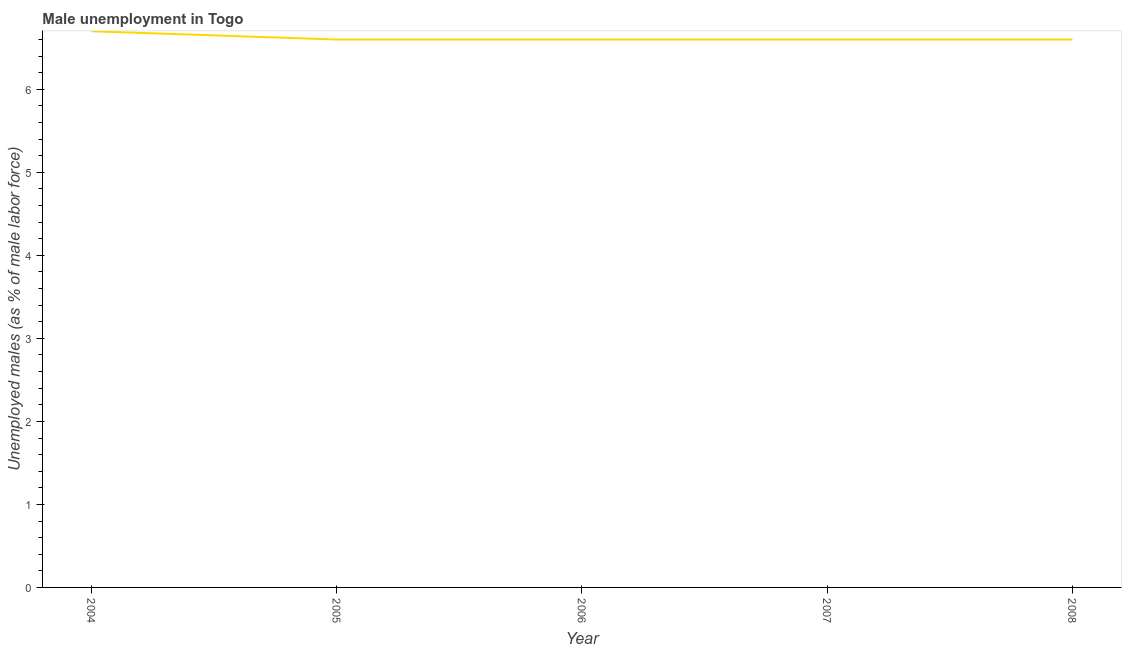What is the unemployed males population in 2007?
Ensure brevity in your answer.  6.6. Across all years, what is the maximum unemployed males population?
Your answer should be very brief. 6.7. Across all years, what is the minimum unemployed males population?
Provide a short and direct response. 6.6. In which year was the unemployed males population minimum?
Your answer should be compact. 2005. What is the sum of the unemployed males population?
Your response must be concise. 33.1. What is the average unemployed males population per year?
Ensure brevity in your answer.  6.62. What is the median unemployed males population?
Keep it short and to the point. 6.6. In how many years, is the unemployed males population greater than 3.6 %?
Offer a terse response. 5. Is the difference between the unemployed males population in 2005 and 2008 greater than the difference between any two years?
Give a very brief answer. No. What is the difference between the highest and the second highest unemployed males population?
Give a very brief answer. 0.1. Is the sum of the unemployed males population in 2004 and 2005 greater than the maximum unemployed males population across all years?
Your response must be concise. Yes. What is the difference between the highest and the lowest unemployed males population?
Provide a succinct answer. 0.1. Does the unemployed males population monotonically increase over the years?
Keep it short and to the point. No. How many years are there in the graph?
Provide a short and direct response. 5. Does the graph contain grids?
Provide a succinct answer. No. What is the title of the graph?
Keep it short and to the point. Male unemployment in Togo. What is the label or title of the X-axis?
Provide a short and direct response. Year. What is the label or title of the Y-axis?
Your answer should be compact. Unemployed males (as % of male labor force). What is the Unemployed males (as % of male labor force) in 2004?
Your response must be concise. 6.7. What is the Unemployed males (as % of male labor force) of 2005?
Your response must be concise. 6.6. What is the Unemployed males (as % of male labor force) of 2006?
Provide a succinct answer. 6.6. What is the Unemployed males (as % of male labor force) of 2007?
Your answer should be compact. 6.6. What is the Unemployed males (as % of male labor force) of 2008?
Your response must be concise. 6.6. What is the difference between the Unemployed males (as % of male labor force) in 2004 and 2006?
Your answer should be compact. 0.1. What is the difference between the Unemployed males (as % of male labor force) in 2005 and 2007?
Give a very brief answer. 0. What is the difference between the Unemployed males (as % of male labor force) in 2006 and 2007?
Provide a succinct answer. 0. What is the difference between the Unemployed males (as % of male labor force) in 2006 and 2008?
Offer a very short reply. 0. What is the difference between the Unemployed males (as % of male labor force) in 2007 and 2008?
Give a very brief answer. 0. What is the ratio of the Unemployed males (as % of male labor force) in 2004 to that in 2005?
Give a very brief answer. 1.01. What is the ratio of the Unemployed males (as % of male labor force) in 2004 to that in 2008?
Provide a short and direct response. 1.01. What is the ratio of the Unemployed males (as % of male labor force) in 2005 to that in 2006?
Your response must be concise. 1. What is the ratio of the Unemployed males (as % of male labor force) in 2005 to that in 2008?
Your answer should be very brief. 1. 